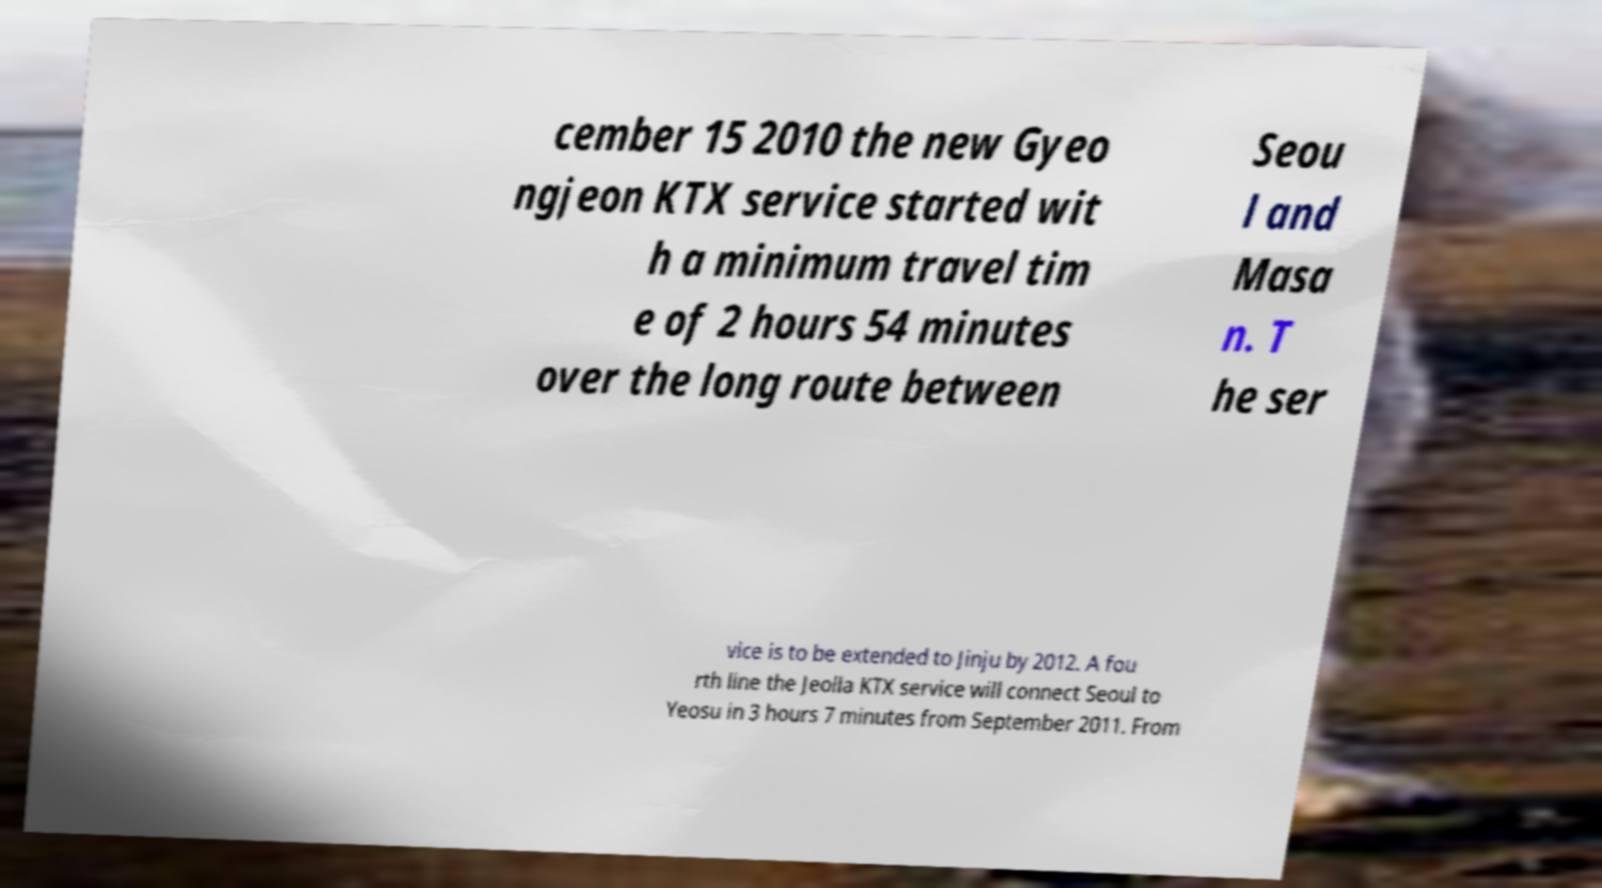There's text embedded in this image that I need extracted. Can you transcribe it verbatim? cember 15 2010 the new Gyeo ngjeon KTX service started wit h a minimum travel tim e of 2 hours 54 minutes over the long route between Seou l and Masa n. T he ser vice is to be extended to Jinju by 2012. A fou rth line the Jeolla KTX service will connect Seoul to Yeosu in 3 hours 7 minutes from September 2011. From 